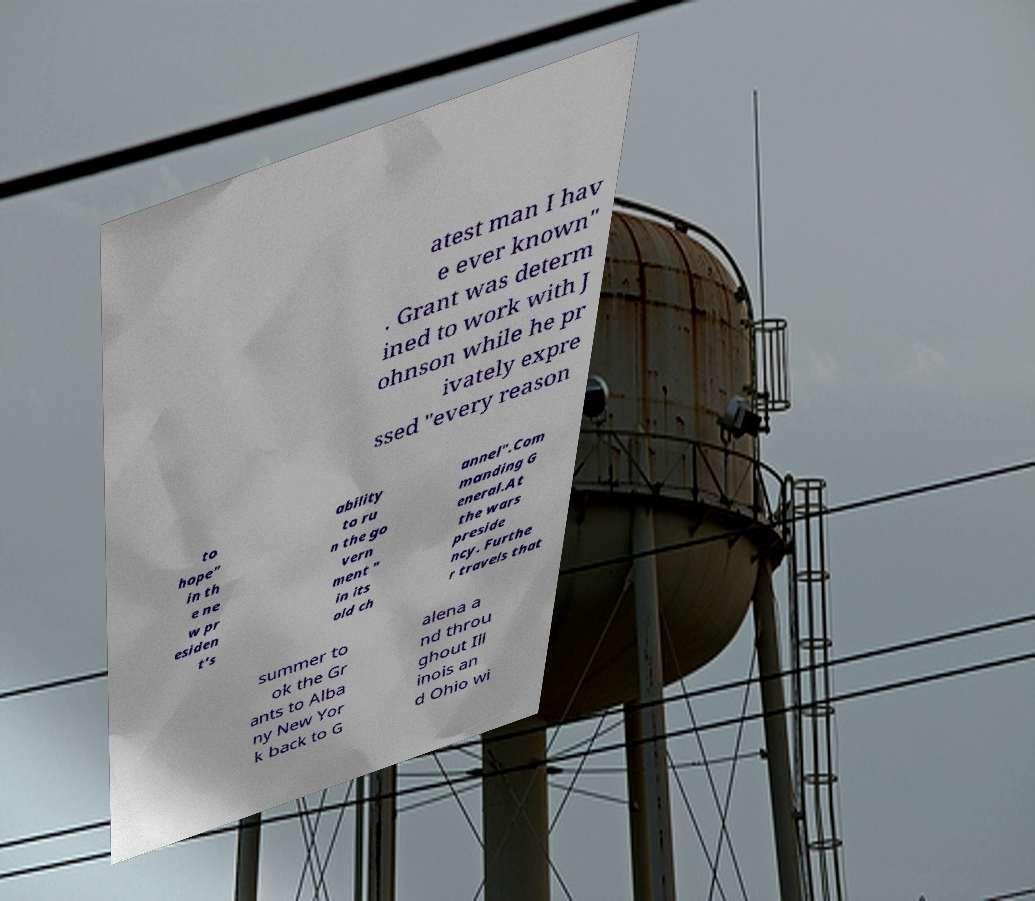Please read and relay the text visible in this image. What does it say? atest man I hav e ever known" . Grant was determ ined to work with J ohnson while he pr ivately expre ssed "every reason to hope" in th e ne w pr esiden t's ability to ru n the go vern ment " in its old ch annel".Com manding G eneral.At the wars preside ncy. Furthe r travels that summer to ok the Gr ants to Alba ny New Yor k back to G alena a nd throu ghout Ill inois an d Ohio wi 